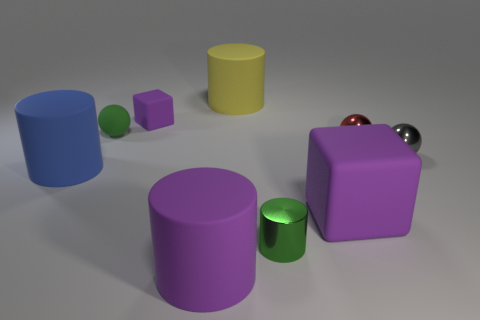Add 1 small rubber objects. How many objects exist? 10 Subtract all green spheres. How many spheres are left? 2 Subtract all gray balls. How many balls are left? 2 Add 3 metal things. How many metal things are left? 6 Add 5 tiny red spheres. How many tiny red spheres exist? 6 Subtract 2 purple cubes. How many objects are left? 7 Subtract all cylinders. How many objects are left? 5 Subtract 2 blocks. How many blocks are left? 0 Subtract all yellow spheres. Subtract all brown cylinders. How many spheres are left? 3 Subtract all gray objects. Subtract all large blue cylinders. How many objects are left? 7 